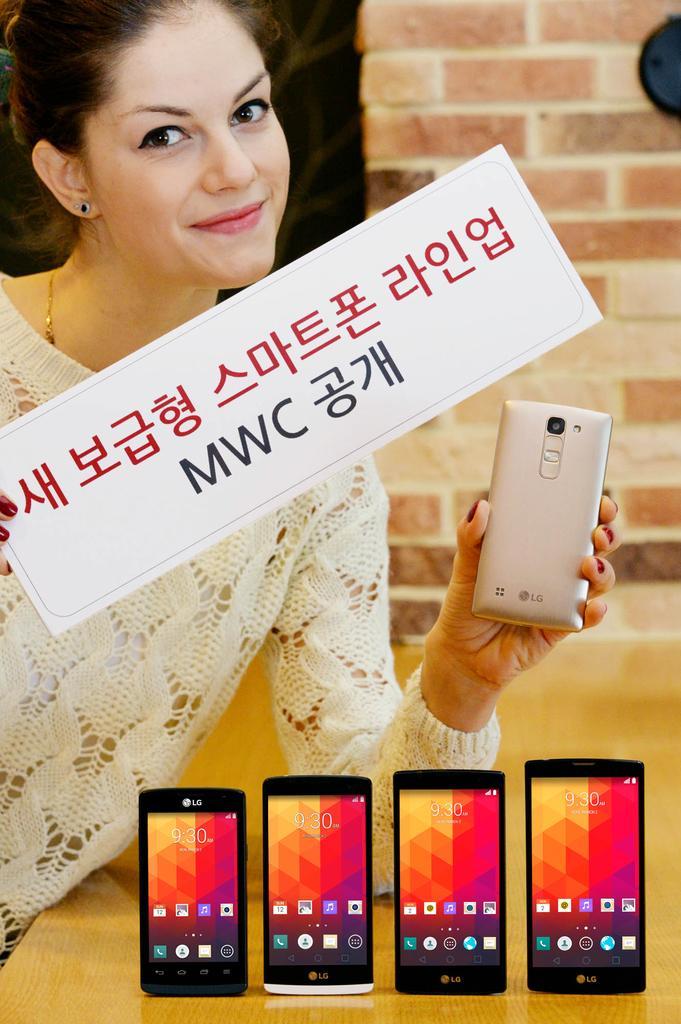Could you give a brief overview of what you see in this image? In this image we can see woman holding a card and a mobile. There are four mobiles on the table. At the background we can see a wall. 